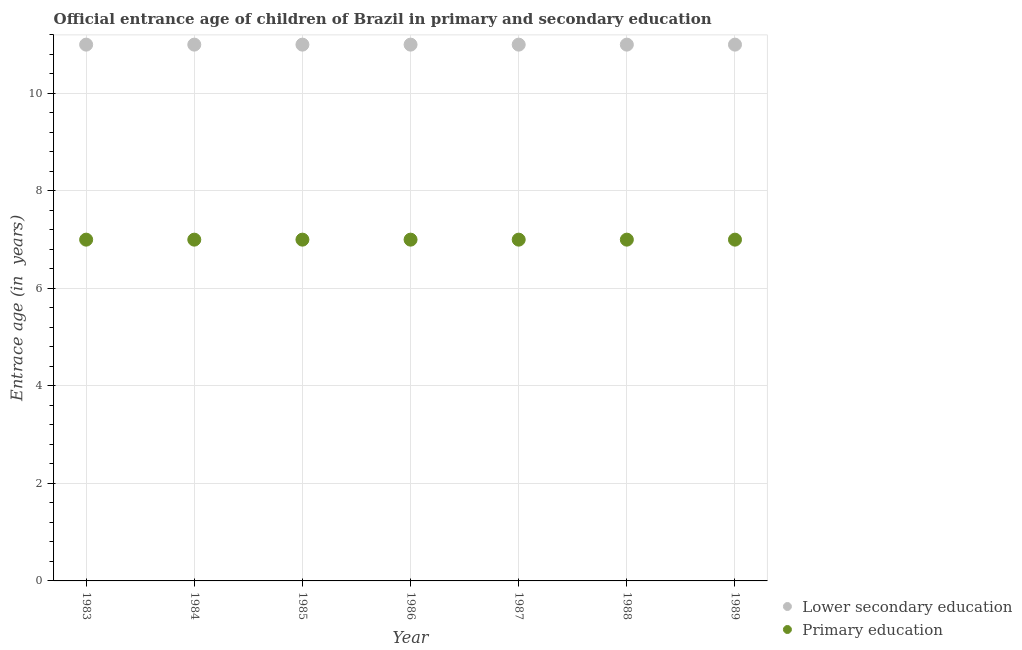Is the number of dotlines equal to the number of legend labels?
Keep it short and to the point. Yes. What is the entrance age of chiildren in primary education in 1984?
Give a very brief answer. 7. Across all years, what is the maximum entrance age of children in lower secondary education?
Your answer should be compact. 11. Across all years, what is the minimum entrance age of children in lower secondary education?
Your response must be concise. 11. In which year was the entrance age of children in lower secondary education minimum?
Keep it short and to the point. 1983. What is the total entrance age of children in lower secondary education in the graph?
Offer a terse response. 77. What is the difference between the entrance age of children in lower secondary education in 1986 and that in 1989?
Your answer should be very brief. 0. What is the difference between the entrance age of chiildren in primary education in 1985 and the entrance age of children in lower secondary education in 1983?
Provide a succinct answer. -4. What is the average entrance age of chiildren in primary education per year?
Ensure brevity in your answer.  7. In the year 1984, what is the difference between the entrance age of children in lower secondary education and entrance age of chiildren in primary education?
Ensure brevity in your answer.  4. What is the ratio of the entrance age of chiildren in primary education in 1984 to that in 1988?
Provide a short and direct response. 1. Is the difference between the entrance age of children in lower secondary education in 1984 and 1985 greater than the difference between the entrance age of chiildren in primary education in 1984 and 1985?
Give a very brief answer. No. What is the difference between the highest and the second highest entrance age of chiildren in primary education?
Your response must be concise. 0. In how many years, is the entrance age of chiildren in primary education greater than the average entrance age of chiildren in primary education taken over all years?
Offer a very short reply. 0. Is the entrance age of children in lower secondary education strictly greater than the entrance age of chiildren in primary education over the years?
Ensure brevity in your answer.  Yes. Is the entrance age of children in lower secondary education strictly less than the entrance age of chiildren in primary education over the years?
Ensure brevity in your answer.  No. How many dotlines are there?
Provide a succinct answer. 2. How many years are there in the graph?
Your answer should be very brief. 7. What is the difference between two consecutive major ticks on the Y-axis?
Your answer should be compact. 2. Are the values on the major ticks of Y-axis written in scientific E-notation?
Ensure brevity in your answer.  No. Does the graph contain any zero values?
Your answer should be compact. No. Does the graph contain grids?
Keep it short and to the point. Yes. What is the title of the graph?
Provide a short and direct response. Official entrance age of children of Brazil in primary and secondary education. What is the label or title of the Y-axis?
Your answer should be compact. Entrace age (in  years). What is the Entrace age (in  years) of Lower secondary education in 1983?
Provide a succinct answer. 11. What is the Entrace age (in  years) in Primary education in 1983?
Offer a very short reply. 7. What is the Entrace age (in  years) of Primary education in 1984?
Provide a short and direct response. 7. What is the Entrace age (in  years) in Primary education in 1985?
Your response must be concise. 7. What is the Entrace age (in  years) in Lower secondary education in 1987?
Ensure brevity in your answer.  11. What is the Entrace age (in  years) of Primary education in 1987?
Your response must be concise. 7. What is the Entrace age (in  years) of Lower secondary education in 1988?
Provide a short and direct response. 11. What is the Entrace age (in  years) in Lower secondary education in 1989?
Make the answer very short. 11. What is the Entrace age (in  years) of Primary education in 1989?
Your answer should be very brief. 7. Across all years, what is the maximum Entrace age (in  years) of Lower secondary education?
Provide a short and direct response. 11. Across all years, what is the minimum Entrace age (in  years) in Lower secondary education?
Your answer should be compact. 11. What is the total Entrace age (in  years) of Primary education in the graph?
Keep it short and to the point. 49. What is the difference between the Entrace age (in  years) of Lower secondary education in 1983 and that in 1984?
Provide a succinct answer. 0. What is the difference between the Entrace age (in  years) of Lower secondary education in 1983 and that in 1985?
Provide a succinct answer. 0. What is the difference between the Entrace age (in  years) of Primary education in 1983 and that in 1985?
Offer a very short reply. 0. What is the difference between the Entrace age (in  years) of Primary education in 1983 and that in 1987?
Your answer should be very brief. 0. What is the difference between the Entrace age (in  years) of Primary education in 1983 and that in 1988?
Offer a very short reply. 0. What is the difference between the Entrace age (in  years) in Primary education in 1984 and that in 1985?
Offer a very short reply. 0. What is the difference between the Entrace age (in  years) of Lower secondary education in 1984 and that in 1986?
Ensure brevity in your answer.  0. What is the difference between the Entrace age (in  years) of Lower secondary education in 1984 and that in 1987?
Ensure brevity in your answer.  0. What is the difference between the Entrace age (in  years) of Primary education in 1984 and that in 1987?
Ensure brevity in your answer.  0. What is the difference between the Entrace age (in  years) of Lower secondary education in 1984 and that in 1988?
Your response must be concise. 0. What is the difference between the Entrace age (in  years) in Primary education in 1984 and that in 1989?
Give a very brief answer. 0. What is the difference between the Entrace age (in  years) of Primary education in 1985 and that in 1986?
Your answer should be compact. 0. What is the difference between the Entrace age (in  years) of Lower secondary education in 1985 and that in 1988?
Ensure brevity in your answer.  0. What is the difference between the Entrace age (in  years) in Primary education in 1985 and that in 1988?
Give a very brief answer. 0. What is the difference between the Entrace age (in  years) in Primary education in 1985 and that in 1989?
Provide a succinct answer. 0. What is the difference between the Entrace age (in  years) in Lower secondary education in 1986 and that in 1987?
Your response must be concise. 0. What is the difference between the Entrace age (in  years) in Primary education in 1986 and that in 1987?
Give a very brief answer. 0. What is the difference between the Entrace age (in  years) of Lower secondary education in 1986 and that in 1989?
Make the answer very short. 0. What is the difference between the Entrace age (in  years) of Lower secondary education in 1987 and that in 1988?
Offer a terse response. 0. What is the difference between the Entrace age (in  years) in Lower secondary education in 1988 and that in 1989?
Provide a short and direct response. 0. What is the difference between the Entrace age (in  years) of Lower secondary education in 1983 and the Entrace age (in  years) of Primary education in 1984?
Offer a terse response. 4. What is the difference between the Entrace age (in  years) in Lower secondary education in 1983 and the Entrace age (in  years) in Primary education in 1986?
Offer a terse response. 4. What is the difference between the Entrace age (in  years) in Lower secondary education in 1983 and the Entrace age (in  years) in Primary education in 1987?
Keep it short and to the point. 4. What is the difference between the Entrace age (in  years) of Lower secondary education in 1983 and the Entrace age (in  years) of Primary education in 1989?
Provide a succinct answer. 4. What is the difference between the Entrace age (in  years) in Lower secondary education in 1984 and the Entrace age (in  years) in Primary education in 1985?
Provide a short and direct response. 4. What is the difference between the Entrace age (in  years) of Lower secondary education in 1984 and the Entrace age (in  years) of Primary education in 1986?
Make the answer very short. 4. What is the difference between the Entrace age (in  years) of Lower secondary education in 1984 and the Entrace age (in  years) of Primary education in 1987?
Offer a very short reply. 4. What is the difference between the Entrace age (in  years) in Lower secondary education in 1984 and the Entrace age (in  years) in Primary education in 1988?
Your answer should be very brief. 4. What is the difference between the Entrace age (in  years) of Lower secondary education in 1985 and the Entrace age (in  years) of Primary education in 1986?
Ensure brevity in your answer.  4. What is the difference between the Entrace age (in  years) of Lower secondary education in 1986 and the Entrace age (in  years) of Primary education in 1987?
Give a very brief answer. 4. What is the difference between the Entrace age (in  years) in Lower secondary education in 1986 and the Entrace age (in  years) in Primary education in 1989?
Provide a succinct answer. 4. What is the average Entrace age (in  years) of Lower secondary education per year?
Your response must be concise. 11. In the year 1985, what is the difference between the Entrace age (in  years) in Lower secondary education and Entrace age (in  years) in Primary education?
Your answer should be very brief. 4. In the year 1987, what is the difference between the Entrace age (in  years) of Lower secondary education and Entrace age (in  years) of Primary education?
Your answer should be very brief. 4. In the year 1988, what is the difference between the Entrace age (in  years) of Lower secondary education and Entrace age (in  years) of Primary education?
Make the answer very short. 4. In the year 1989, what is the difference between the Entrace age (in  years) in Lower secondary education and Entrace age (in  years) in Primary education?
Keep it short and to the point. 4. What is the ratio of the Entrace age (in  years) in Primary education in 1983 to that in 1984?
Offer a very short reply. 1. What is the ratio of the Entrace age (in  years) in Lower secondary education in 1983 to that in 1985?
Offer a terse response. 1. What is the ratio of the Entrace age (in  years) of Lower secondary education in 1983 to that in 1987?
Offer a terse response. 1. What is the ratio of the Entrace age (in  years) of Lower secondary education in 1983 to that in 1988?
Provide a succinct answer. 1. What is the ratio of the Entrace age (in  years) of Primary education in 1983 to that in 1988?
Make the answer very short. 1. What is the ratio of the Entrace age (in  years) of Lower secondary education in 1984 to that in 1986?
Your response must be concise. 1. What is the ratio of the Entrace age (in  years) in Primary education in 1984 to that in 1986?
Your response must be concise. 1. What is the ratio of the Entrace age (in  years) in Primary education in 1984 to that in 1988?
Give a very brief answer. 1. What is the ratio of the Entrace age (in  years) of Lower secondary education in 1984 to that in 1989?
Your response must be concise. 1. What is the ratio of the Entrace age (in  years) of Lower secondary education in 1985 to that in 1987?
Make the answer very short. 1. What is the ratio of the Entrace age (in  years) of Primary education in 1985 to that in 1987?
Give a very brief answer. 1. What is the ratio of the Entrace age (in  years) in Lower secondary education in 1985 to that in 1988?
Offer a very short reply. 1. What is the ratio of the Entrace age (in  years) of Lower secondary education in 1985 to that in 1989?
Provide a succinct answer. 1. What is the ratio of the Entrace age (in  years) of Primary education in 1985 to that in 1989?
Give a very brief answer. 1. What is the ratio of the Entrace age (in  years) in Lower secondary education in 1986 to that in 1987?
Give a very brief answer. 1. What is the ratio of the Entrace age (in  years) in Primary education in 1986 to that in 1987?
Offer a terse response. 1. What is the ratio of the Entrace age (in  years) of Lower secondary education in 1986 to that in 1989?
Make the answer very short. 1. What is the ratio of the Entrace age (in  years) of Lower secondary education in 1987 to that in 1988?
Keep it short and to the point. 1. What is the ratio of the Entrace age (in  years) of Lower secondary education in 1987 to that in 1989?
Ensure brevity in your answer.  1. What is the ratio of the Entrace age (in  years) in Primary education in 1987 to that in 1989?
Give a very brief answer. 1. What is the difference between the highest and the second highest Entrace age (in  years) in Primary education?
Your answer should be compact. 0. What is the difference between the highest and the lowest Entrace age (in  years) of Primary education?
Provide a short and direct response. 0. 